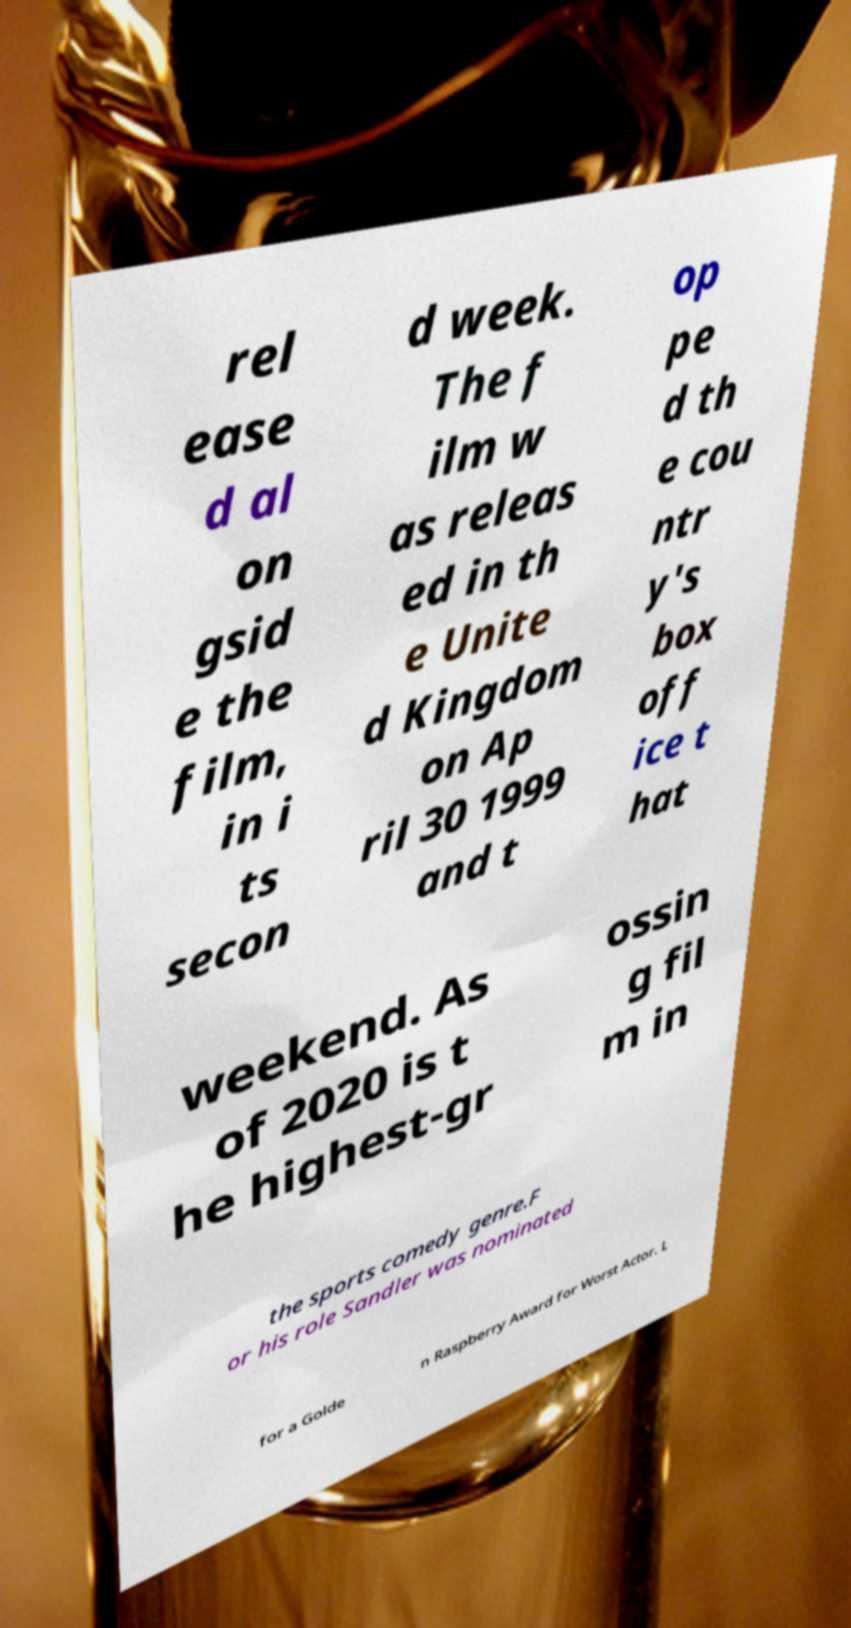For documentation purposes, I need the text within this image transcribed. Could you provide that? rel ease d al on gsid e the film, in i ts secon d week. The f ilm w as releas ed in th e Unite d Kingdom on Ap ril 30 1999 and t op pe d th e cou ntr y's box off ice t hat weekend. As of 2020 is t he highest-gr ossin g fil m in the sports comedy genre.F or his role Sandler was nominated for a Golde n Raspberry Award for Worst Actor. L 